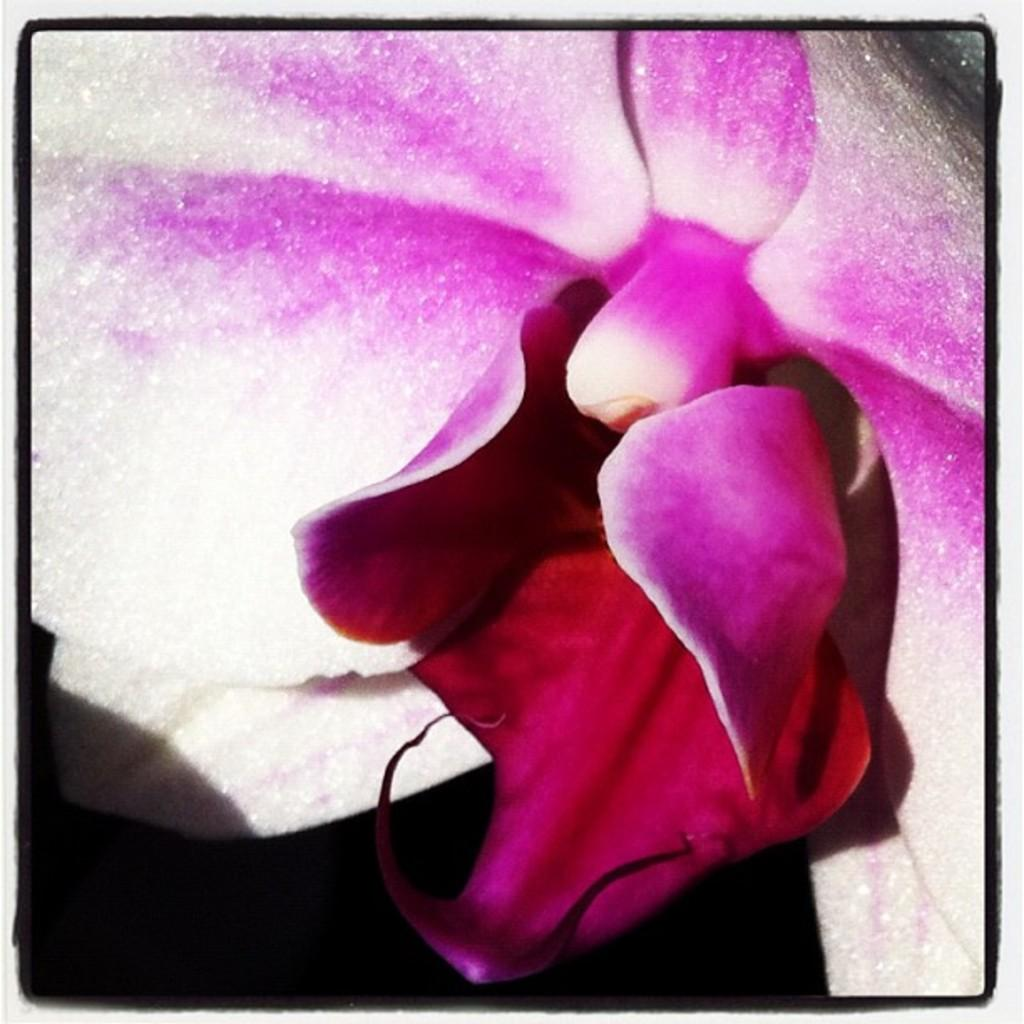What is the main subject of the image? There is a flower in the image. Can you describe the color or appearance of the flower? The provided facts do not mention the color or appearance of the flower. What is the lighting condition at the bottom of the image? The bottom of the image is dark. What type of brass instrument is being played in the image? There is no brass instrument present in the image; it only features a flower. How many holes can be seen in the flower in the image? Flowers do not have holes like those found in some objects, so this question cannot be answered based on the provided facts. 